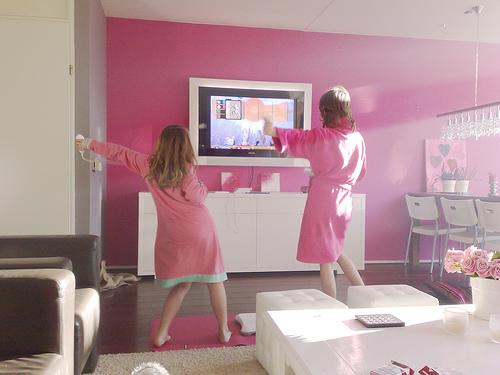What is featured by the TV? video game 